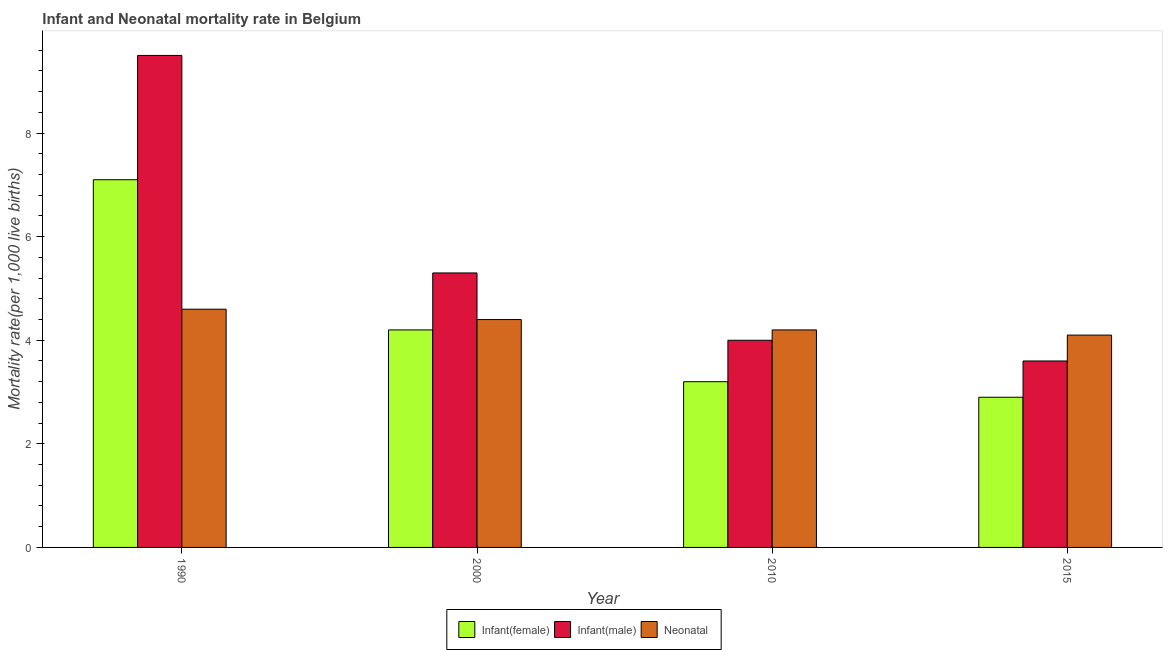How many groups of bars are there?
Offer a terse response. 4. Are the number of bars per tick equal to the number of legend labels?
Offer a very short reply. Yes. How many bars are there on the 3rd tick from the left?
Offer a very short reply. 3. What is the label of the 3rd group of bars from the left?
Keep it short and to the point. 2010. What is the infant mortality rate(male) in 2015?
Your response must be concise. 3.6. Across all years, what is the maximum infant mortality rate(male)?
Your response must be concise. 9.5. In which year was the neonatal mortality rate minimum?
Give a very brief answer. 2015. What is the total infant mortality rate(male) in the graph?
Provide a short and direct response. 22.4. What is the difference between the neonatal mortality rate in 1990 and that in 2015?
Provide a succinct answer. 0.5. What is the difference between the infant mortality rate(female) in 2000 and the infant mortality rate(male) in 1990?
Make the answer very short. -2.9. What is the average infant mortality rate(male) per year?
Provide a succinct answer. 5.6. In how many years, is the infant mortality rate(male) greater than 2.8?
Ensure brevity in your answer.  4. What is the ratio of the neonatal mortality rate in 2000 to that in 2010?
Provide a succinct answer. 1.05. What is the difference between the highest and the second highest neonatal mortality rate?
Offer a very short reply. 0.2. What is the difference between the highest and the lowest infant mortality rate(female)?
Provide a succinct answer. 4.2. In how many years, is the infant mortality rate(female) greater than the average infant mortality rate(female) taken over all years?
Ensure brevity in your answer.  1. Is the sum of the neonatal mortality rate in 2000 and 2010 greater than the maximum infant mortality rate(female) across all years?
Your response must be concise. Yes. What does the 3rd bar from the left in 2010 represents?
Your answer should be compact. Neonatal . What does the 2nd bar from the right in 1990 represents?
Your answer should be compact. Infant(male). Are all the bars in the graph horizontal?
Your answer should be compact. No. How many years are there in the graph?
Provide a succinct answer. 4. Where does the legend appear in the graph?
Offer a very short reply. Bottom center. How many legend labels are there?
Your answer should be compact. 3. What is the title of the graph?
Offer a very short reply. Infant and Neonatal mortality rate in Belgium. Does "Poland" appear as one of the legend labels in the graph?
Keep it short and to the point. No. What is the label or title of the X-axis?
Offer a very short reply. Year. What is the label or title of the Y-axis?
Your answer should be very brief. Mortality rate(per 1,0 live births). What is the Mortality rate(per 1,000 live births) of Infant(male) in 1990?
Provide a succinct answer. 9.5. What is the Mortality rate(per 1,000 live births) in Infant(female) in 2000?
Ensure brevity in your answer.  4.2. What is the Mortality rate(per 1,000 live births) of Infant(male) in 2010?
Provide a succinct answer. 4. What is the Mortality rate(per 1,000 live births) of Neonatal  in 2010?
Provide a succinct answer. 4.2. What is the Mortality rate(per 1,000 live births) in Infant(male) in 2015?
Make the answer very short. 3.6. Across all years, what is the maximum Mortality rate(per 1,000 live births) of Infant(female)?
Offer a very short reply. 7.1. Across all years, what is the maximum Mortality rate(per 1,000 live births) in Infant(male)?
Offer a terse response. 9.5. Across all years, what is the maximum Mortality rate(per 1,000 live births) in Neonatal ?
Your answer should be very brief. 4.6. Across all years, what is the minimum Mortality rate(per 1,000 live births) of Infant(male)?
Offer a very short reply. 3.6. Across all years, what is the minimum Mortality rate(per 1,000 live births) of Neonatal ?
Your response must be concise. 4.1. What is the total Mortality rate(per 1,000 live births) of Infant(male) in the graph?
Offer a very short reply. 22.4. What is the total Mortality rate(per 1,000 live births) of Neonatal  in the graph?
Your answer should be very brief. 17.3. What is the difference between the Mortality rate(per 1,000 live births) in Infant(male) in 1990 and that in 2000?
Make the answer very short. 4.2. What is the difference between the Mortality rate(per 1,000 live births) in Neonatal  in 1990 and that in 2000?
Give a very brief answer. 0.2. What is the difference between the Mortality rate(per 1,000 live births) in Infant(female) in 1990 and that in 2010?
Offer a terse response. 3.9. What is the difference between the Mortality rate(per 1,000 live births) of Neonatal  in 1990 and that in 2015?
Keep it short and to the point. 0.5. What is the difference between the Mortality rate(per 1,000 live births) of Infant(male) in 2000 and that in 2010?
Make the answer very short. 1.3. What is the difference between the Mortality rate(per 1,000 live births) of Neonatal  in 2000 and that in 2010?
Give a very brief answer. 0.2. What is the difference between the Mortality rate(per 1,000 live births) of Infant(male) in 2000 and that in 2015?
Offer a very short reply. 1.7. What is the difference between the Mortality rate(per 1,000 live births) in Neonatal  in 2000 and that in 2015?
Ensure brevity in your answer.  0.3. What is the difference between the Mortality rate(per 1,000 live births) of Infant(female) in 2010 and that in 2015?
Make the answer very short. 0.3. What is the difference between the Mortality rate(per 1,000 live births) in Infant(male) in 2010 and that in 2015?
Your answer should be compact. 0.4. What is the difference between the Mortality rate(per 1,000 live births) of Infant(male) in 1990 and the Mortality rate(per 1,000 live births) of Neonatal  in 2000?
Your answer should be very brief. 5.1. What is the difference between the Mortality rate(per 1,000 live births) of Infant(female) in 1990 and the Mortality rate(per 1,000 live births) of Neonatal  in 2010?
Make the answer very short. 2.9. What is the difference between the Mortality rate(per 1,000 live births) in Infant(male) in 1990 and the Mortality rate(per 1,000 live births) in Neonatal  in 2010?
Keep it short and to the point. 5.3. What is the difference between the Mortality rate(per 1,000 live births) in Infant(female) in 1990 and the Mortality rate(per 1,000 live births) in Infant(male) in 2015?
Ensure brevity in your answer.  3.5. What is the difference between the Mortality rate(per 1,000 live births) in Infant(male) in 1990 and the Mortality rate(per 1,000 live births) in Neonatal  in 2015?
Make the answer very short. 5.4. What is the difference between the Mortality rate(per 1,000 live births) of Infant(female) in 2000 and the Mortality rate(per 1,000 live births) of Infant(male) in 2010?
Your answer should be compact. 0.2. What is the difference between the Mortality rate(per 1,000 live births) in Infant(female) in 2000 and the Mortality rate(per 1,000 live births) in Neonatal  in 2015?
Make the answer very short. 0.1. What is the difference between the Mortality rate(per 1,000 live births) in Infant(male) in 2000 and the Mortality rate(per 1,000 live births) in Neonatal  in 2015?
Your answer should be very brief. 1.2. What is the average Mortality rate(per 1,000 live births) of Infant(female) per year?
Your answer should be very brief. 4.35. What is the average Mortality rate(per 1,000 live births) of Neonatal  per year?
Offer a terse response. 4.33. In the year 1990, what is the difference between the Mortality rate(per 1,000 live births) in Infant(female) and Mortality rate(per 1,000 live births) in Infant(male)?
Offer a very short reply. -2.4. In the year 2000, what is the difference between the Mortality rate(per 1,000 live births) of Infant(female) and Mortality rate(per 1,000 live births) of Neonatal ?
Provide a short and direct response. -0.2. In the year 2010, what is the difference between the Mortality rate(per 1,000 live births) in Infant(female) and Mortality rate(per 1,000 live births) in Infant(male)?
Your answer should be very brief. -0.8. In the year 2015, what is the difference between the Mortality rate(per 1,000 live births) of Infant(male) and Mortality rate(per 1,000 live births) of Neonatal ?
Give a very brief answer. -0.5. What is the ratio of the Mortality rate(per 1,000 live births) in Infant(female) in 1990 to that in 2000?
Your answer should be compact. 1.69. What is the ratio of the Mortality rate(per 1,000 live births) in Infant(male) in 1990 to that in 2000?
Provide a short and direct response. 1.79. What is the ratio of the Mortality rate(per 1,000 live births) in Neonatal  in 1990 to that in 2000?
Ensure brevity in your answer.  1.05. What is the ratio of the Mortality rate(per 1,000 live births) in Infant(female) in 1990 to that in 2010?
Give a very brief answer. 2.22. What is the ratio of the Mortality rate(per 1,000 live births) in Infant(male) in 1990 to that in 2010?
Your answer should be very brief. 2.38. What is the ratio of the Mortality rate(per 1,000 live births) of Neonatal  in 1990 to that in 2010?
Ensure brevity in your answer.  1.1. What is the ratio of the Mortality rate(per 1,000 live births) in Infant(female) in 1990 to that in 2015?
Offer a very short reply. 2.45. What is the ratio of the Mortality rate(per 1,000 live births) in Infant(male) in 1990 to that in 2015?
Give a very brief answer. 2.64. What is the ratio of the Mortality rate(per 1,000 live births) of Neonatal  in 1990 to that in 2015?
Your response must be concise. 1.12. What is the ratio of the Mortality rate(per 1,000 live births) of Infant(female) in 2000 to that in 2010?
Give a very brief answer. 1.31. What is the ratio of the Mortality rate(per 1,000 live births) in Infant(male) in 2000 to that in 2010?
Your response must be concise. 1.32. What is the ratio of the Mortality rate(per 1,000 live births) in Neonatal  in 2000 to that in 2010?
Ensure brevity in your answer.  1.05. What is the ratio of the Mortality rate(per 1,000 live births) in Infant(female) in 2000 to that in 2015?
Make the answer very short. 1.45. What is the ratio of the Mortality rate(per 1,000 live births) in Infant(male) in 2000 to that in 2015?
Offer a terse response. 1.47. What is the ratio of the Mortality rate(per 1,000 live births) in Neonatal  in 2000 to that in 2015?
Your answer should be very brief. 1.07. What is the ratio of the Mortality rate(per 1,000 live births) of Infant(female) in 2010 to that in 2015?
Your answer should be compact. 1.1. What is the ratio of the Mortality rate(per 1,000 live births) in Neonatal  in 2010 to that in 2015?
Your response must be concise. 1.02. What is the difference between the highest and the second highest Mortality rate(per 1,000 live births) of Infant(male)?
Your answer should be very brief. 4.2. What is the difference between the highest and the second highest Mortality rate(per 1,000 live births) of Neonatal ?
Offer a terse response. 0.2. What is the difference between the highest and the lowest Mortality rate(per 1,000 live births) of Infant(female)?
Offer a very short reply. 4.2. What is the difference between the highest and the lowest Mortality rate(per 1,000 live births) of Infant(male)?
Offer a very short reply. 5.9. What is the difference between the highest and the lowest Mortality rate(per 1,000 live births) in Neonatal ?
Give a very brief answer. 0.5. 